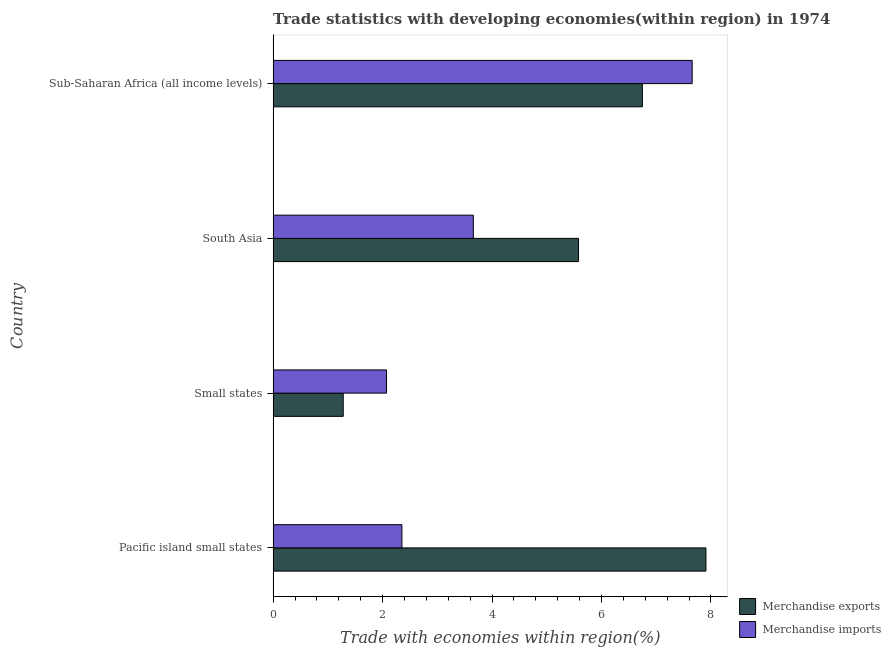How many different coloured bars are there?
Make the answer very short. 2. How many groups of bars are there?
Your answer should be compact. 4. Are the number of bars per tick equal to the number of legend labels?
Your answer should be compact. Yes. Are the number of bars on each tick of the Y-axis equal?
Provide a short and direct response. Yes. What is the label of the 3rd group of bars from the top?
Your response must be concise. Small states. What is the merchandise exports in Small states?
Your response must be concise. 1.28. Across all countries, what is the maximum merchandise exports?
Offer a terse response. 7.91. Across all countries, what is the minimum merchandise imports?
Provide a succinct answer. 2.07. In which country was the merchandise exports maximum?
Your answer should be compact. Pacific island small states. In which country was the merchandise imports minimum?
Offer a very short reply. Small states. What is the total merchandise exports in the graph?
Offer a very short reply. 21.52. What is the difference between the merchandise exports in Pacific island small states and that in South Asia?
Keep it short and to the point. 2.33. What is the difference between the merchandise exports in Pacific island small states and the merchandise imports in Sub-Saharan Africa (all income levels)?
Give a very brief answer. 0.25. What is the average merchandise exports per country?
Ensure brevity in your answer.  5.38. What is the difference between the merchandise exports and merchandise imports in Sub-Saharan Africa (all income levels)?
Your answer should be very brief. -0.91. What is the ratio of the merchandise exports in Pacific island small states to that in Sub-Saharan Africa (all income levels)?
Offer a terse response. 1.17. Is the merchandise exports in Pacific island small states less than that in South Asia?
Provide a succinct answer. No. What is the difference between the highest and the second highest merchandise imports?
Your answer should be compact. 4. What is the difference between the highest and the lowest merchandise imports?
Ensure brevity in your answer.  5.59. Is the sum of the merchandise exports in Small states and Sub-Saharan Africa (all income levels) greater than the maximum merchandise imports across all countries?
Keep it short and to the point. Yes. What does the 2nd bar from the bottom in Small states represents?
Keep it short and to the point. Merchandise imports. Are all the bars in the graph horizontal?
Your answer should be very brief. Yes. How many countries are there in the graph?
Your answer should be compact. 4. What is the difference between two consecutive major ticks on the X-axis?
Make the answer very short. 2. Does the graph contain grids?
Provide a succinct answer. No. How many legend labels are there?
Give a very brief answer. 2. How are the legend labels stacked?
Your response must be concise. Vertical. What is the title of the graph?
Give a very brief answer. Trade statistics with developing economies(within region) in 1974. Does "Primary income" appear as one of the legend labels in the graph?
Give a very brief answer. No. What is the label or title of the X-axis?
Provide a short and direct response. Trade with economies within region(%). What is the Trade with economies within region(%) in Merchandise exports in Pacific island small states?
Your answer should be compact. 7.91. What is the Trade with economies within region(%) of Merchandise imports in Pacific island small states?
Your answer should be compact. 2.35. What is the Trade with economies within region(%) of Merchandise exports in Small states?
Ensure brevity in your answer.  1.28. What is the Trade with economies within region(%) in Merchandise imports in Small states?
Give a very brief answer. 2.07. What is the Trade with economies within region(%) of Merchandise exports in South Asia?
Your response must be concise. 5.58. What is the Trade with economies within region(%) of Merchandise imports in South Asia?
Ensure brevity in your answer.  3.66. What is the Trade with economies within region(%) in Merchandise exports in Sub-Saharan Africa (all income levels)?
Ensure brevity in your answer.  6.75. What is the Trade with economies within region(%) of Merchandise imports in Sub-Saharan Africa (all income levels)?
Keep it short and to the point. 7.66. Across all countries, what is the maximum Trade with economies within region(%) in Merchandise exports?
Offer a terse response. 7.91. Across all countries, what is the maximum Trade with economies within region(%) in Merchandise imports?
Offer a terse response. 7.66. Across all countries, what is the minimum Trade with economies within region(%) of Merchandise exports?
Provide a short and direct response. 1.28. Across all countries, what is the minimum Trade with economies within region(%) in Merchandise imports?
Your answer should be compact. 2.07. What is the total Trade with economies within region(%) in Merchandise exports in the graph?
Provide a succinct answer. 21.52. What is the total Trade with economies within region(%) in Merchandise imports in the graph?
Make the answer very short. 15.74. What is the difference between the Trade with economies within region(%) of Merchandise exports in Pacific island small states and that in Small states?
Make the answer very short. 6.63. What is the difference between the Trade with economies within region(%) in Merchandise imports in Pacific island small states and that in Small states?
Offer a terse response. 0.28. What is the difference between the Trade with economies within region(%) of Merchandise exports in Pacific island small states and that in South Asia?
Offer a terse response. 2.33. What is the difference between the Trade with economies within region(%) of Merchandise imports in Pacific island small states and that in South Asia?
Your answer should be very brief. -1.31. What is the difference between the Trade with economies within region(%) in Merchandise exports in Pacific island small states and that in Sub-Saharan Africa (all income levels)?
Make the answer very short. 1.16. What is the difference between the Trade with economies within region(%) in Merchandise imports in Pacific island small states and that in Sub-Saharan Africa (all income levels)?
Keep it short and to the point. -5.3. What is the difference between the Trade with economies within region(%) of Merchandise imports in Small states and that in South Asia?
Offer a very short reply. -1.59. What is the difference between the Trade with economies within region(%) of Merchandise exports in Small states and that in Sub-Saharan Africa (all income levels)?
Your response must be concise. -5.47. What is the difference between the Trade with economies within region(%) of Merchandise imports in Small states and that in Sub-Saharan Africa (all income levels)?
Provide a short and direct response. -5.59. What is the difference between the Trade with economies within region(%) of Merchandise exports in South Asia and that in Sub-Saharan Africa (all income levels)?
Make the answer very short. -1.17. What is the difference between the Trade with economies within region(%) of Merchandise imports in South Asia and that in Sub-Saharan Africa (all income levels)?
Keep it short and to the point. -4. What is the difference between the Trade with economies within region(%) in Merchandise exports in Pacific island small states and the Trade with economies within region(%) in Merchandise imports in Small states?
Make the answer very short. 5.84. What is the difference between the Trade with economies within region(%) in Merchandise exports in Pacific island small states and the Trade with economies within region(%) in Merchandise imports in South Asia?
Your answer should be compact. 4.25. What is the difference between the Trade with economies within region(%) of Merchandise exports in Pacific island small states and the Trade with economies within region(%) of Merchandise imports in Sub-Saharan Africa (all income levels)?
Provide a succinct answer. 0.25. What is the difference between the Trade with economies within region(%) of Merchandise exports in Small states and the Trade with economies within region(%) of Merchandise imports in South Asia?
Keep it short and to the point. -2.38. What is the difference between the Trade with economies within region(%) of Merchandise exports in Small states and the Trade with economies within region(%) of Merchandise imports in Sub-Saharan Africa (all income levels)?
Offer a terse response. -6.38. What is the difference between the Trade with economies within region(%) in Merchandise exports in South Asia and the Trade with economies within region(%) in Merchandise imports in Sub-Saharan Africa (all income levels)?
Provide a succinct answer. -2.08. What is the average Trade with economies within region(%) in Merchandise exports per country?
Your answer should be very brief. 5.38. What is the average Trade with economies within region(%) of Merchandise imports per country?
Ensure brevity in your answer.  3.94. What is the difference between the Trade with economies within region(%) of Merchandise exports and Trade with economies within region(%) of Merchandise imports in Pacific island small states?
Keep it short and to the point. 5.56. What is the difference between the Trade with economies within region(%) in Merchandise exports and Trade with economies within region(%) in Merchandise imports in Small states?
Make the answer very short. -0.79. What is the difference between the Trade with economies within region(%) of Merchandise exports and Trade with economies within region(%) of Merchandise imports in South Asia?
Offer a very short reply. 1.92. What is the difference between the Trade with economies within region(%) in Merchandise exports and Trade with economies within region(%) in Merchandise imports in Sub-Saharan Africa (all income levels)?
Your answer should be very brief. -0.91. What is the ratio of the Trade with economies within region(%) in Merchandise exports in Pacific island small states to that in Small states?
Make the answer very short. 6.17. What is the ratio of the Trade with economies within region(%) of Merchandise imports in Pacific island small states to that in Small states?
Your answer should be compact. 1.14. What is the ratio of the Trade with economies within region(%) of Merchandise exports in Pacific island small states to that in South Asia?
Your answer should be very brief. 1.42. What is the ratio of the Trade with economies within region(%) of Merchandise imports in Pacific island small states to that in South Asia?
Provide a succinct answer. 0.64. What is the ratio of the Trade with economies within region(%) in Merchandise exports in Pacific island small states to that in Sub-Saharan Africa (all income levels)?
Your answer should be compact. 1.17. What is the ratio of the Trade with economies within region(%) in Merchandise imports in Pacific island small states to that in Sub-Saharan Africa (all income levels)?
Your response must be concise. 0.31. What is the ratio of the Trade with economies within region(%) of Merchandise exports in Small states to that in South Asia?
Provide a succinct answer. 0.23. What is the ratio of the Trade with economies within region(%) in Merchandise imports in Small states to that in South Asia?
Make the answer very short. 0.57. What is the ratio of the Trade with economies within region(%) of Merchandise exports in Small states to that in Sub-Saharan Africa (all income levels)?
Provide a succinct answer. 0.19. What is the ratio of the Trade with economies within region(%) of Merchandise imports in Small states to that in Sub-Saharan Africa (all income levels)?
Ensure brevity in your answer.  0.27. What is the ratio of the Trade with economies within region(%) in Merchandise exports in South Asia to that in Sub-Saharan Africa (all income levels)?
Your answer should be compact. 0.83. What is the ratio of the Trade with economies within region(%) in Merchandise imports in South Asia to that in Sub-Saharan Africa (all income levels)?
Make the answer very short. 0.48. What is the difference between the highest and the second highest Trade with economies within region(%) of Merchandise exports?
Give a very brief answer. 1.16. What is the difference between the highest and the second highest Trade with economies within region(%) of Merchandise imports?
Your response must be concise. 4. What is the difference between the highest and the lowest Trade with economies within region(%) in Merchandise exports?
Make the answer very short. 6.63. What is the difference between the highest and the lowest Trade with economies within region(%) in Merchandise imports?
Keep it short and to the point. 5.59. 